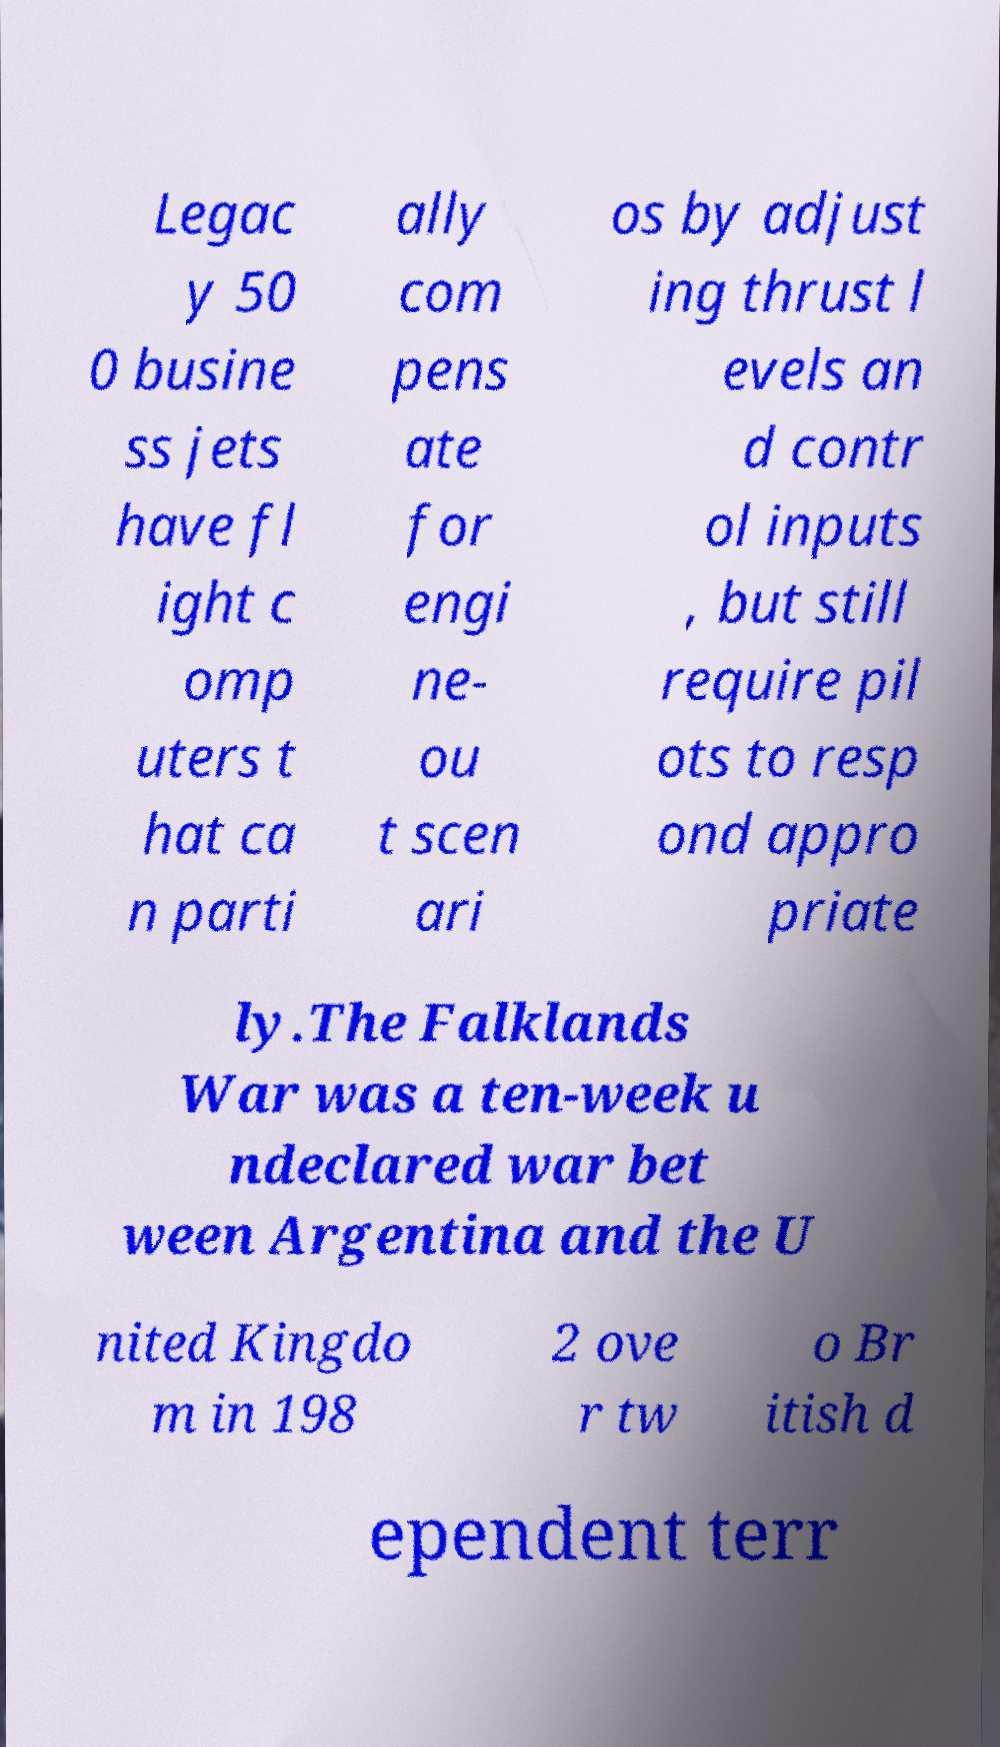Please read and relay the text visible in this image. What does it say? Legac y 50 0 busine ss jets have fl ight c omp uters t hat ca n parti ally com pens ate for engi ne- ou t scen ari os by adjust ing thrust l evels an d contr ol inputs , but still require pil ots to resp ond appro priate ly.The Falklands War was a ten-week u ndeclared war bet ween Argentina and the U nited Kingdo m in 198 2 ove r tw o Br itish d ependent terr 